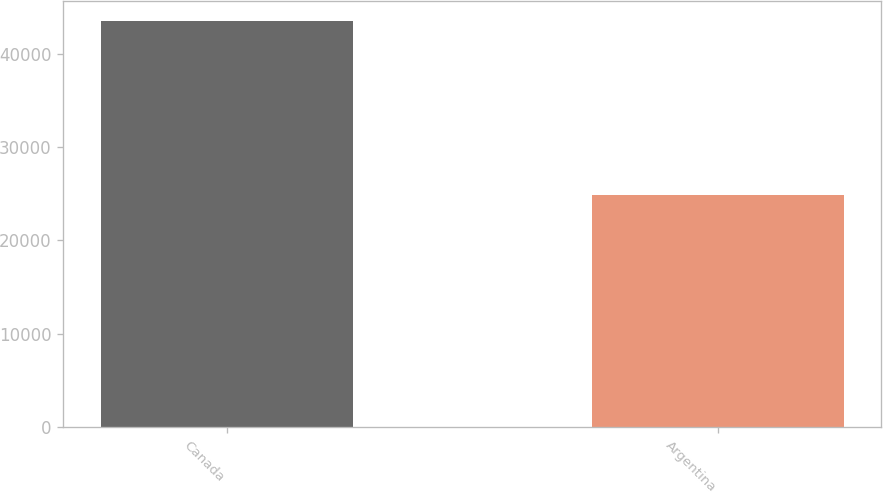Convert chart. <chart><loc_0><loc_0><loc_500><loc_500><bar_chart><fcel>Canada<fcel>Argentina<nl><fcel>43437<fcel>24893<nl></chart> 